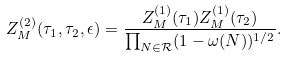Convert formula to latex. <formula><loc_0><loc_0><loc_500><loc_500>Z _ { M } ^ { ( 2 ) } ( \tau _ { 1 } , \tau _ { 2 } , \epsilon ) = \frac { Z _ { M } ^ { ( 1 ) } ( \tau _ { 1 } ) Z _ { M } ^ { ( 1 ) } ( \tau _ { 2 } ) } { \prod _ { N \in \mathcal { R } } ( 1 - \omega ( N ) ) ^ { 1 / 2 } } .</formula> 